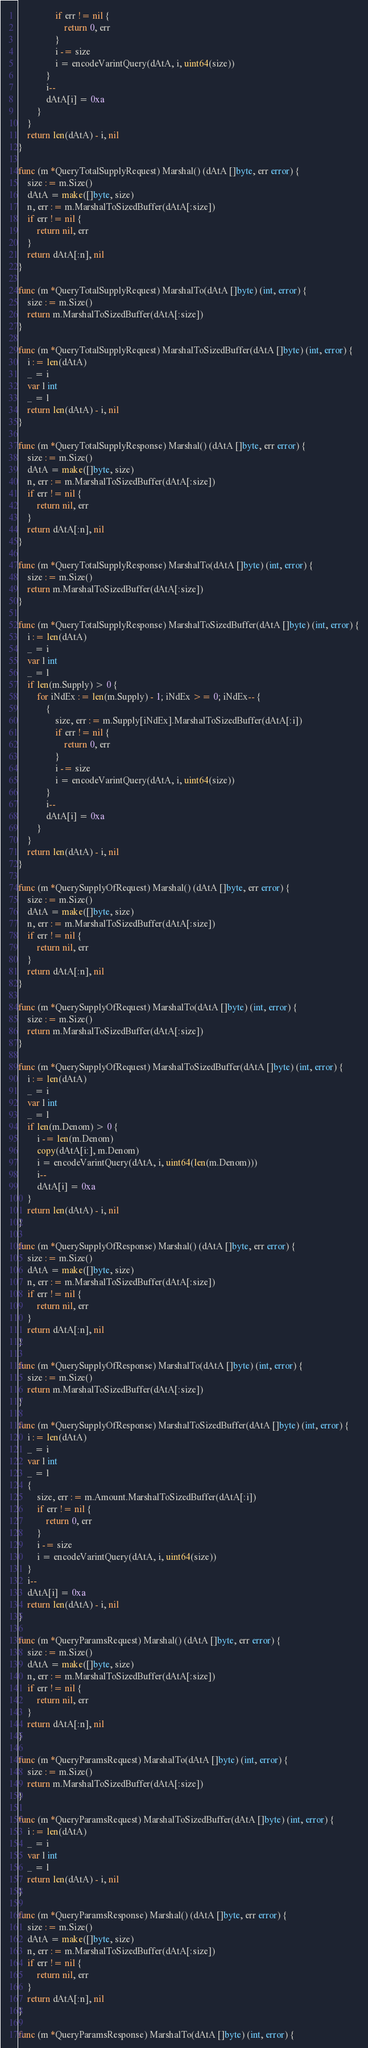<code> <loc_0><loc_0><loc_500><loc_500><_Go_>				if err != nil {
					return 0, err
				}
				i -= size
				i = encodeVarintQuery(dAtA, i, uint64(size))
			}
			i--
			dAtA[i] = 0xa
		}
	}
	return len(dAtA) - i, nil
}

func (m *QueryTotalSupplyRequest) Marshal() (dAtA []byte, err error) {
	size := m.Size()
	dAtA = make([]byte, size)
	n, err := m.MarshalToSizedBuffer(dAtA[:size])
	if err != nil {
		return nil, err
	}
	return dAtA[:n], nil
}

func (m *QueryTotalSupplyRequest) MarshalTo(dAtA []byte) (int, error) {
	size := m.Size()
	return m.MarshalToSizedBuffer(dAtA[:size])
}

func (m *QueryTotalSupplyRequest) MarshalToSizedBuffer(dAtA []byte) (int, error) {
	i := len(dAtA)
	_ = i
	var l int
	_ = l
	return len(dAtA) - i, nil
}

func (m *QueryTotalSupplyResponse) Marshal() (dAtA []byte, err error) {
	size := m.Size()
	dAtA = make([]byte, size)
	n, err := m.MarshalToSizedBuffer(dAtA[:size])
	if err != nil {
		return nil, err
	}
	return dAtA[:n], nil
}

func (m *QueryTotalSupplyResponse) MarshalTo(dAtA []byte) (int, error) {
	size := m.Size()
	return m.MarshalToSizedBuffer(dAtA[:size])
}

func (m *QueryTotalSupplyResponse) MarshalToSizedBuffer(dAtA []byte) (int, error) {
	i := len(dAtA)
	_ = i
	var l int
	_ = l
	if len(m.Supply) > 0 {
		for iNdEx := len(m.Supply) - 1; iNdEx >= 0; iNdEx-- {
			{
				size, err := m.Supply[iNdEx].MarshalToSizedBuffer(dAtA[:i])
				if err != nil {
					return 0, err
				}
				i -= size
				i = encodeVarintQuery(dAtA, i, uint64(size))
			}
			i--
			dAtA[i] = 0xa
		}
	}
	return len(dAtA) - i, nil
}

func (m *QuerySupplyOfRequest) Marshal() (dAtA []byte, err error) {
	size := m.Size()
	dAtA = make([]byte, size)
	n, err := m.MarshalToSizedBuffer(dAtA[:size])
	if err != nil {
		return nil, err
	}
	return dAtA[:n], nil
}

func (m *QuerySupplyOfRequest) MarshalTo(dAtA []byte) (int, error) {
	size := m.Size()
	return m.MarshalToSizedBuffer(dAtA[:size])
}

func (m *QuerySupplyOfRequest) MarshalToSizedBuffer(dAtA []byte) (int, error) {
	i := len(dAtA)
	_ = i
	var l int
	_ = l
	if len(m.Denom) > 0 {
		i -= len(m.Denom)
		copy(dAtA[i:], m.Denom)
		i = encodeVarintQuery(dAtA, i, uint64(len(m.Denom)))
		i--
		dAtA[i] = 0xa
	}
	return len(dAtA) - i, nil
}

func (m *QuerySupplyOfResponse) Marshal() (dAtA []byte, err error) {
	size := m.Size()
	dAtA = make([]byte, size)
	n, err := m.MarshalToSizedBuffer(dAtA[:size])
	if err != nil {
		return nil, err
	}
	return dAtA[:n], nil
}

func (m *QuerySupplyOfResponse) MarshalTo(dAtA []byte) (int, error) {
	size := m.Size()
	return m.MarshalToSizedBuffer(dAtA[:size])
}

func (m *QuerySupplyOfResponse) MarshalToSizedBuffer(dAtA []byte) (int, error) {
	i := len(dAtA)
	_ = i
	var l int
	_ = l
	{
		size, err := m.Amount.MarshalToSizedBuffer(dAtA[:i])
		if err != nil {
			return 0, err
		}
		i -= size
		i = encodeVarintQuery(dAtA, i, uint64(size))
	}
	i--
	dAtA[i] = 0xa
	return len(dAtA) - i, nil
}

func (m *QueryParamsRequest) Marshal() (dAtA []byte, err error) {
	size := m.Size()
	dAtA = make([]byte, size)
	n, err := m.MarshalToSizedBuffer(dAtA[:size])
	if err != nil {
		return nil, err
	}
	return dAtA[:n], nil
}

func (m *QueryParamsRequest) MarshalTo(dAtA []byte) (int, error) {
	size := m.Size()
	return m.MarshalToSizedBuffer(dAtA[:size])
}

func (m *QueryParamsRequest) MarshalToSizedBuffer(dAtA []byte) (int, error) {
	i := len(dAtA)
	_ = i
	var l int
	_ = l
	return len(dAtA) - i, nil
}

func (m *QueryParamsResponse) Marshal() (dAtA []byte, err error) {
	size := m.Size()
	dAtA = make([]byte, size)
	n, err := m.MarshalToSizedBuffer(dAtA[:size])
	if err != nil {
		return nil, err
	}
	return dAtA[:n], nil
}

func (m *QueryParamsResponse) MarshalTo(dAtA []byte) (int, error) {</code> 